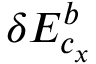<formula> <loc_0><loc_0><loc_500><loc_500>\delta E _ { c _ { x } } ^ { b }</formula> 